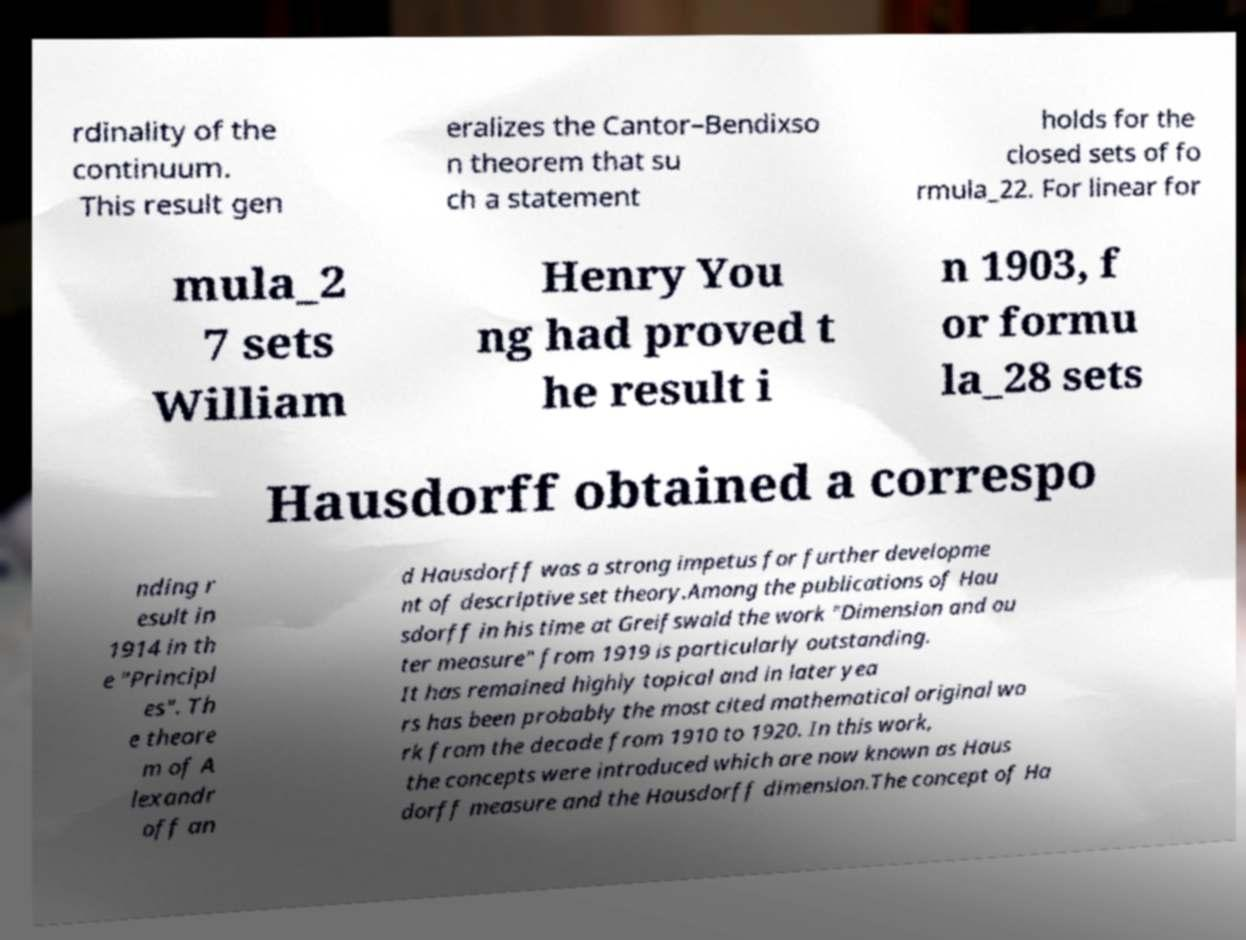Can you accurately transcribe the text from the provided image for me? rdinality of the continuum. This result gen eralizes the Cantor–Bendixso n theorem that su ch a statement holds for the closed sets of fo rmula_22. For linear for mula_2 7 sets William Henry You ng had proved t he result i n 1903, f or formu la_28 sets Hausdorff obtained a correspo nding r esult in 1914 in th e "Principl es". Th e theore m of A lexandr off an d Hausdorff was a strong impetus for further developme nt of descriptive set theory.Among the publications of Hau sdorff in his time at Greifswald the work "Dimension and ou ter measure" from 1919 is particularly outstanding. It has remained highly topical and in later yea rs has been probably the most cited mathematical original wo rk from the decade from 1910 to 1920. In this work, the concepts were introduced which are now known as Haus dorff measure and the Hausdorff dimension.The concept of Ha 